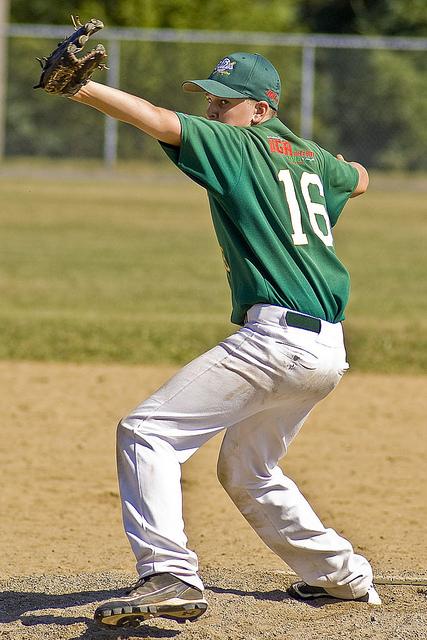What color is he wearing?
Quick response, please. Green. What does the number 16 signify?
Keep it brief. Team number. What position does he play?
Keep it brief. Pitcher. Is he a pro?
Write a very short answer. No. Is his hat soft of hard?
Give a very brief answer. Soft. What is the man's dominant hand?
Write a very short answer. Right. What brand of glove is the player using?
Give a very brief answer. Wilson. 